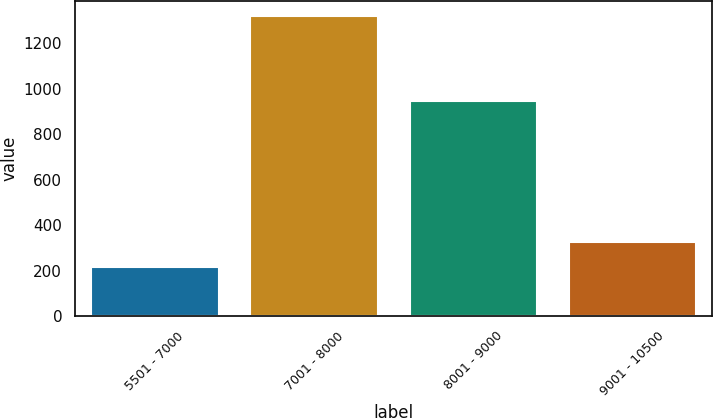Convert chart to OTSL. <chart><loc_0><loc_0><loc_500><loc_500><bar_chart><fcel>5501 - 7000<fcel>7001 - 8000<fcel>8001 - 9000<fcel>9001 - 10500<nl><fcel>218<fcel>1320<fcel>947<fcel>328.2<nl></chart> 